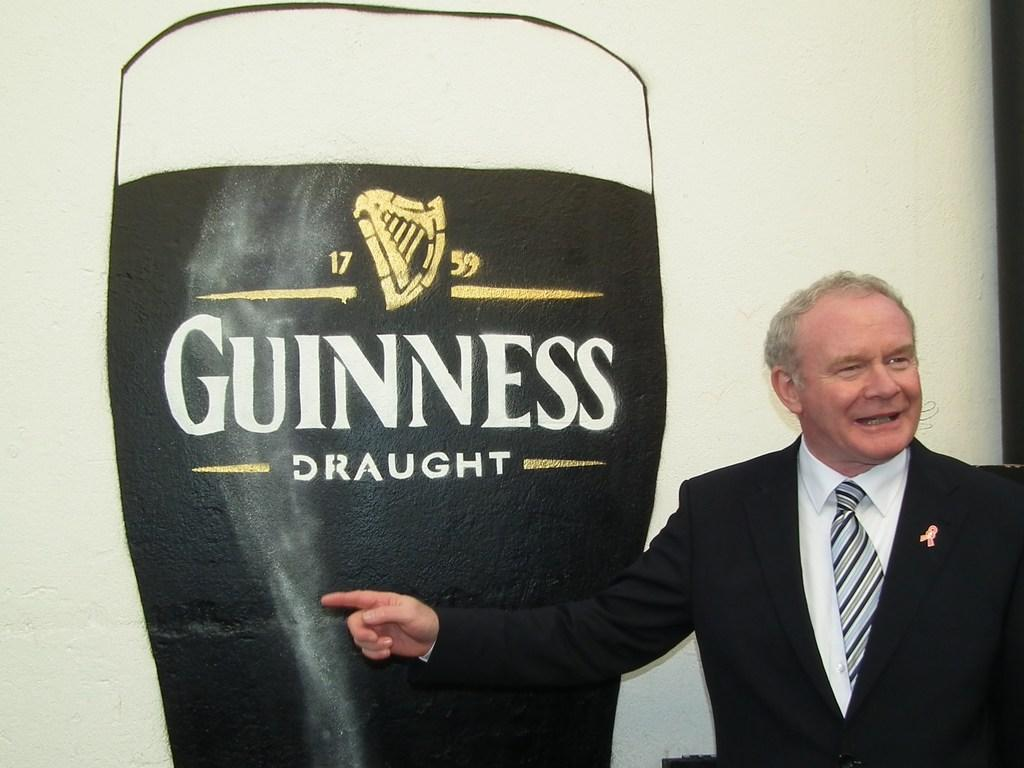What is the man in the image wearing? The man is wearing a suit and a tie. What can be seen in the background of the image? There is a banner in the background of the image. What is depicted on the banner? The banner contains a picture of a glass. What else is present on the banner? There is text on the banner. What type of scarecrow can be seen in the image? There is no scarecrow present in the image. What is the man's title or position, as indicated by the text on the banner? The provided facts do not mention the man's title or position, nor does the text on the banner indicate it. 